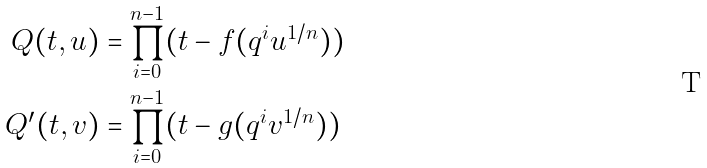<formula> <loc_0><loc_0><loc_500><loc_500>Q ( t , u ) & = \prod _ { i = 0 } ^ { n - 1 } ( t - f ( q ^ { i } u ^ { 1 / n } ) ) \\ Q ^ { \prime } ( t , v ) & = \prod _ { i = 0 } ^ { n - 1 } ( t - g ( q ^ { i } v ^ { 1 / n } ) )</formula> 